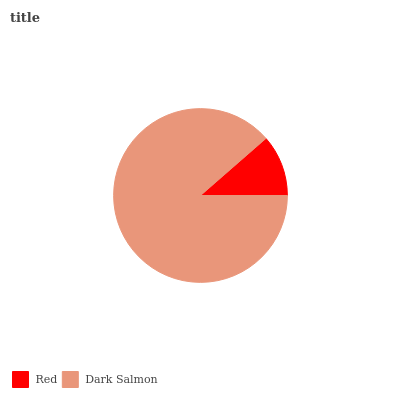Is Red the minimum?
Answer yes or no. Yes. Is Dark Salmon the maximum?
Answer yes or no. Yes. Is Dark Salmon the minimum?
Answer yes or no. No. Is Dark Salmon greater than Red?
Answer yes or no. Yes. Is Red less than Dark Salmon?
Answer yes or no. Yes. Is Red greater than Dark Salmon?
Answer yes or no. No. Is Dark Salmon less than Red?
Answer yes or no. No. Is Dark Salmon the high median?
Answer yes or no. Yes. Is Red the low median?
Answer yes or no. Yes. Is Red the high median?
Answer yes or no. No. Is Dark Salmon the low median?
Answer yes or no. No. 